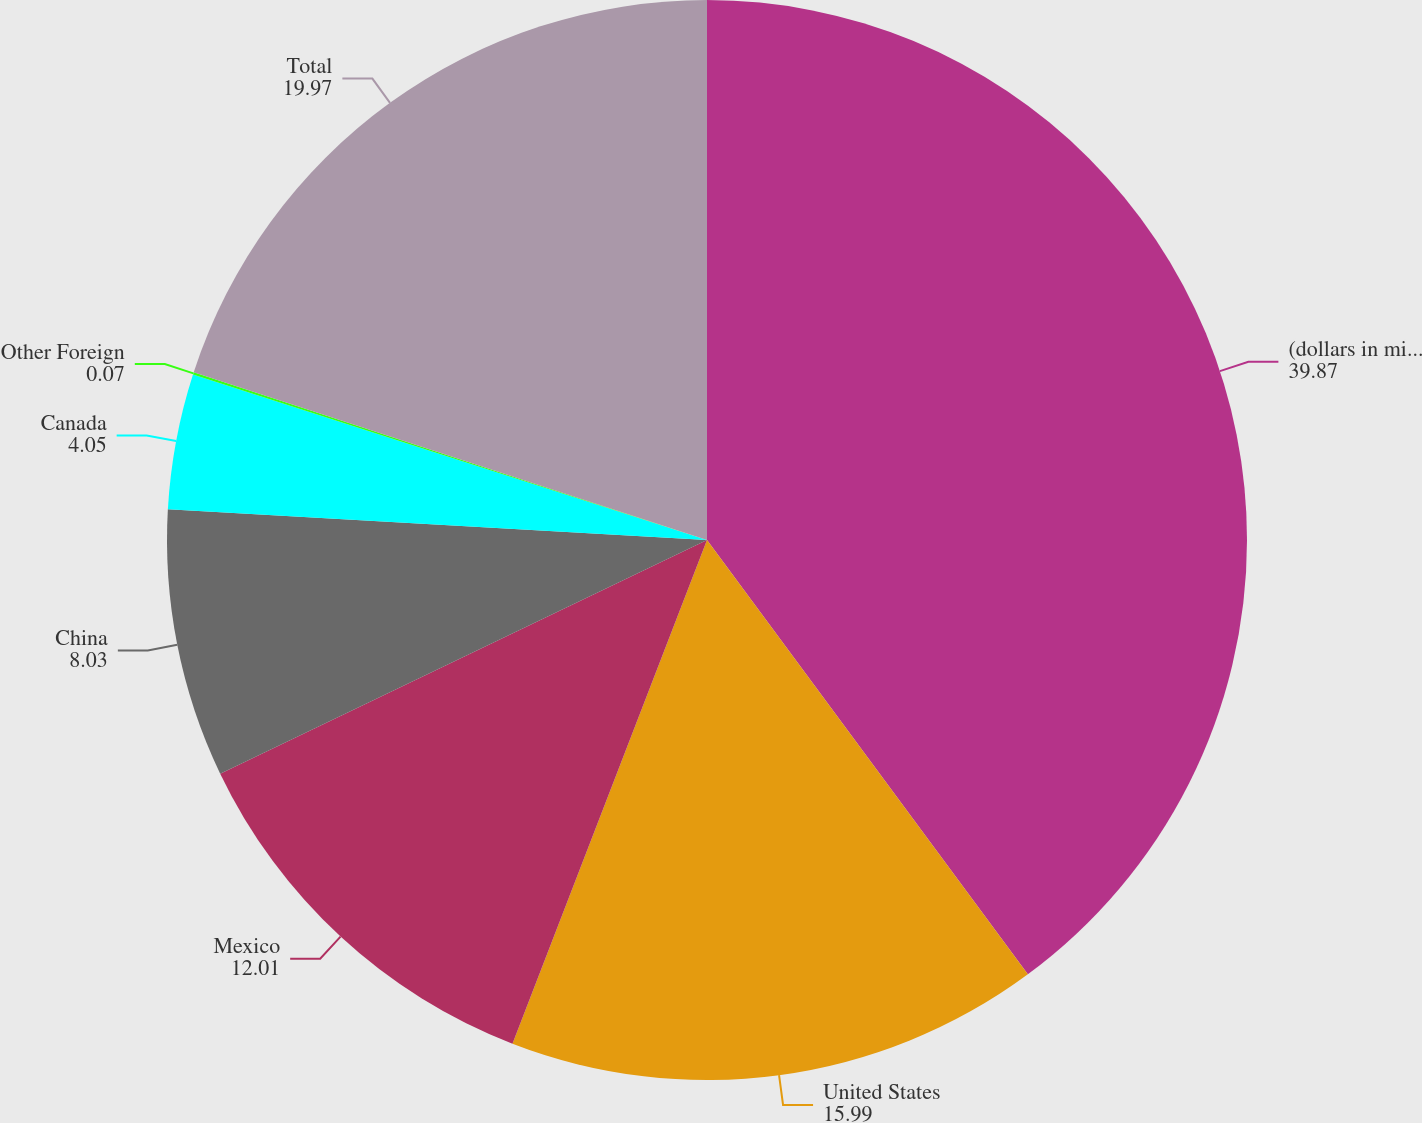Convert chart to OTSL. <chart><loc_0><loc_0><loc_500><loc_500><pie_chart><fcel>(dollars in millions)<fcel>United States<fcel>Mexico<fcel>China<fcel>Canada<fcel>Other Foreign<fcel>Total<nl><fcel>39.87%<fcel>15.99%<fcel>12.01%<fcel>8.03%<fcel>4.05%<fcel>0.07%<fcel>19.97%<nl></chart> 